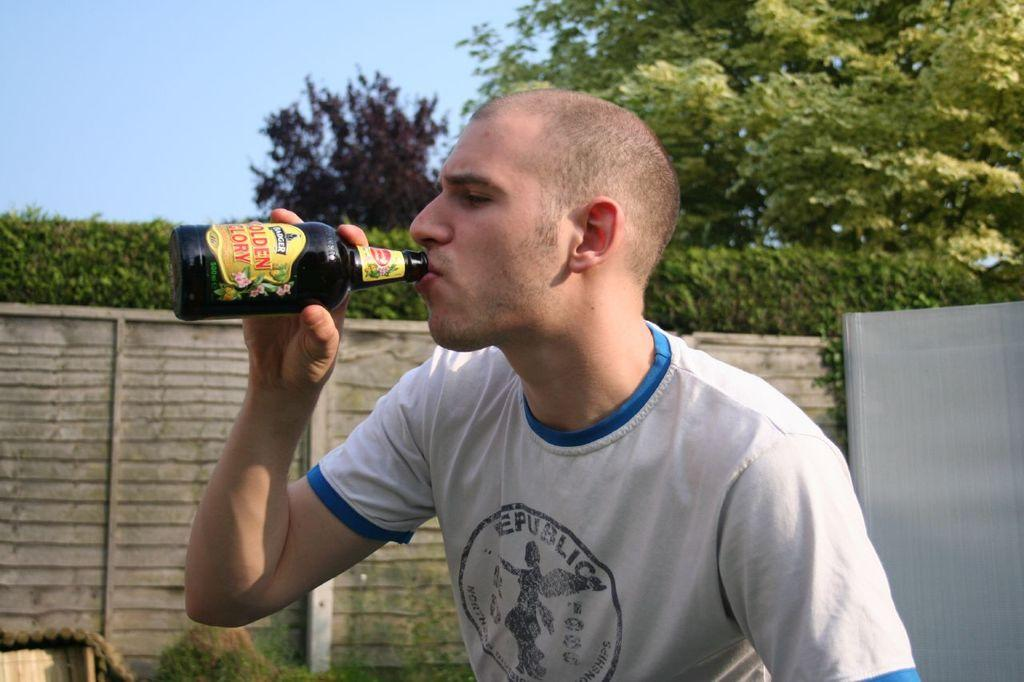Who is present in the image? There is a man in the image. What is the man holding in his hand? The man is holding a bottle in his hand. What is the man doing with the bottle? The man is drinking from the bottle. What can be seen in the background of the image? There is a wall, a tree, and the sky visible in the background of the image. What type of creature is sitting on the faucet in the image? There is no faucet or creature present in the image. 